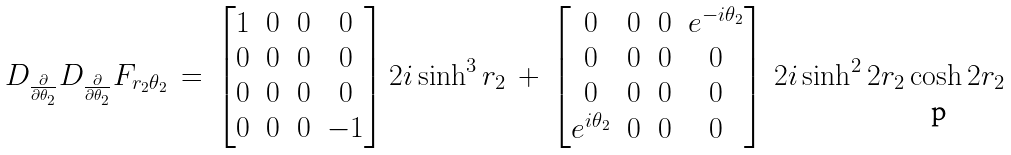<formula> <loc_0><loc_0><loc_500><loc_500>D _ { \frac { \partial } { \partial \theta _ { 2 } } } D _ { \frac { \partial } { \partial \theta _ { 2 } } } F _ { r _ { 2 } \theta _ { 2 } } \, = \, \left [ \begin{matrix} 1 & 0 & 0 & 0 \\ 0 & 0 & 0 & 0 \\ 0 & 0 & 0 & 0 \\ 0 & 0 & 0 & - 1 \end{matrix} \right ] 2 i \sinh ^ { 3 } r _ { 2 } \, + \, \left [ \begin{matrix} 0 & 0 & 0 & e ^ { - i \theta _ { 2 } } \\ 0 & 0 & 0 & 0 \\ 0 & 0 & 0 & 0 \\ e ^ { i \theta _ { 2 } } & 0 & 0 & 0 \end{matrix} \right ] \, 2 i \sinh ^ { 2 } 2 r _ { 2 } \cosh 2 r _ { 2 }</formula> 